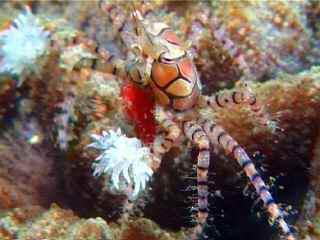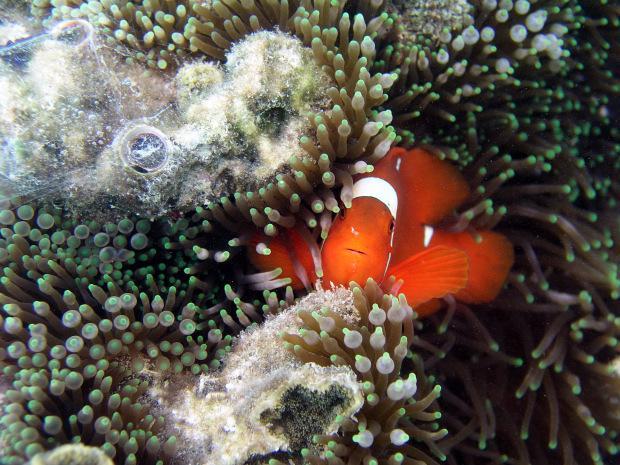The first image is the image on the left, the second image is the image on the right. Examine the images to the left and right. Is the description "One image includes two close together fish that are bright orange with white stripe, and the other image includes a yellower fish with white stripes." accurate? Answer yes or no. No. 